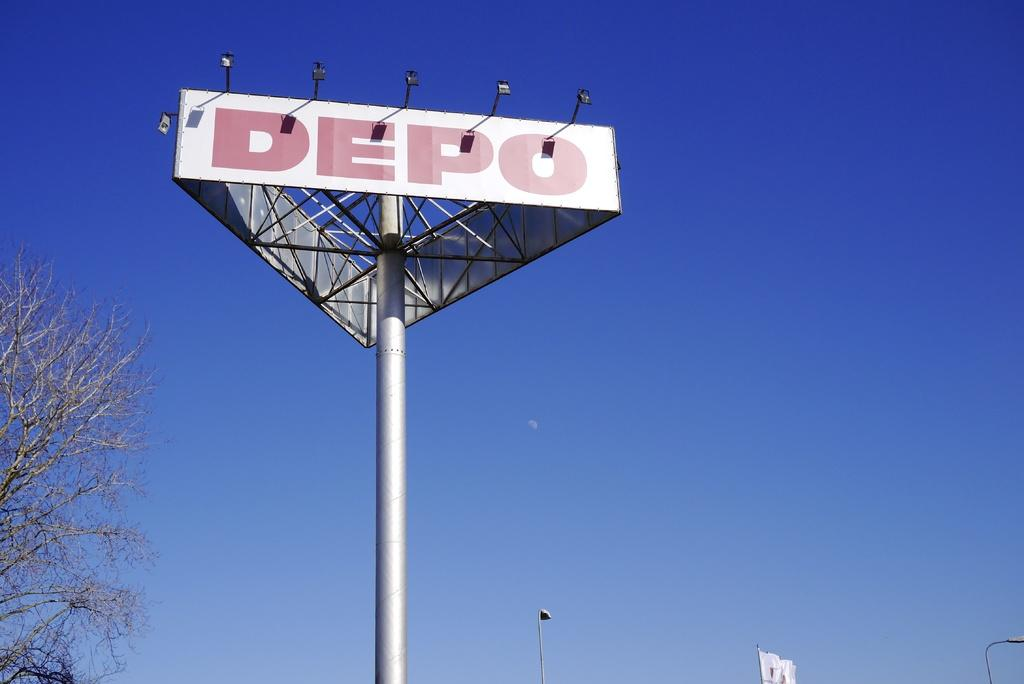<image>
Create a compact narrative representing the image presented. A large lighted sign for DEPO against the backdrop of a blue sky. 